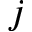<formula> <loc_0><loc_0><loc_500><loc_500>j</formula> 